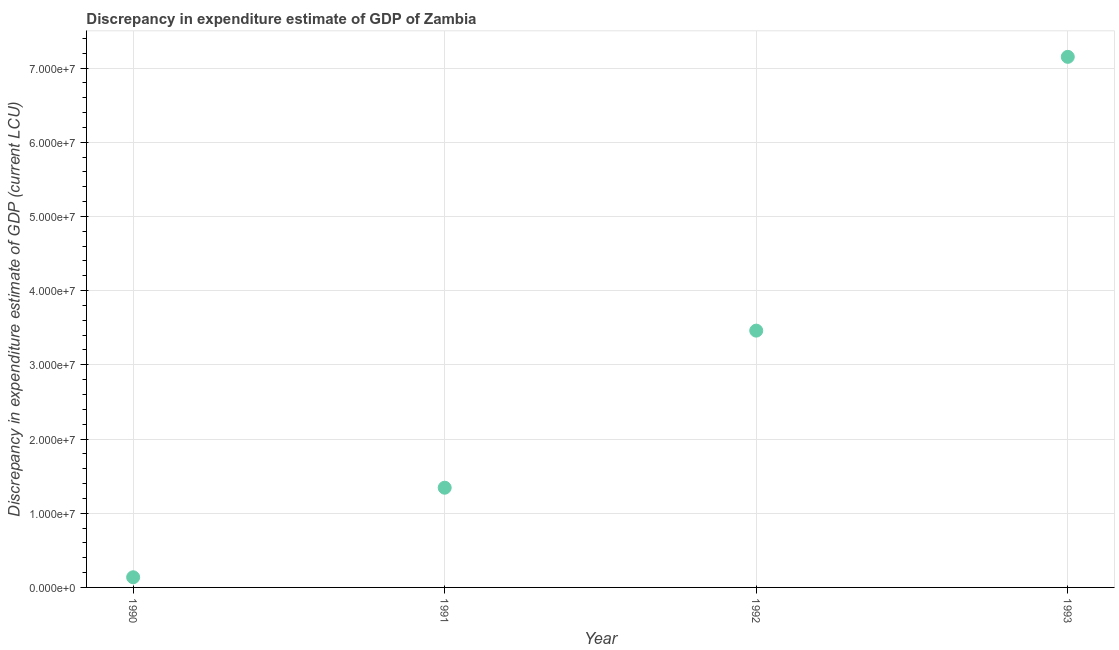What is the discrepancy in expenditure estimate of gdp in 1990?
Keep it short and to the point. 1.37e+06. Across all years, what is the maximum discrepancy in expenditure estimate of gdp?
Your response must be concise. 7.15e+07. Across all years, what is the minimum discrepancy in expenditure estimate of gdp?
Offer a terse response. 1.37e+06. In which year was the discrepancy in expenditure estimate of gdp maximum?
Your response must be concise. 1993. What is the sum of the discrepancy in expenditure estimate of gdp?
Offer a terse response. 1.21e+08. What is the difference between the discrepancy in expenditure estimate of gdp in 1990 and 1992?
Your answer should be compact. -3.32e+07. What is the average discrepancy in expenditure estimate of gdp per year?
Give a very brief answer. 3.02e+07. What is the median discrepancy in expenditure estimate of gdp?
Your answer should be compact. 2.40e+07. Do a majority of the years between 1991 and 1992 (inclusive) have discrepancy in expenditure estimate of gdp greater than 44000000 LCU?
Your response must be concise. No. What is the ratio of the discrepancy in expenditure estimate of gdp in 1992 to that in 1993?
Your answer should be compact. 0.48. What is the difference between the highest and the second highest discrepancy in expenditure estimate of gdp?
Keep it short and to the point. 3.69e+07. Is the sum of the discrepancy in expenditure estimate of gdp in 1990 and 1992 greater than the maximum discrepancy in expenditure estimate of gdp across all years?
Ensure brevity in your answer.  No. What is the difference between the highest and the lowest discrepancy in expenditure estimate of gdp?
Make the answer very short. 7.01e+07. In how many years, is the discrepancy in expenditure estimate of gdp greater than the average discrepancy in expenditure estimate of gdp taken over all years?
Provide a succinct answer. 2. How many dotlines are there?
Offer a terse response. 1. What is the difference between two consecutive major ticks on the Y-axis?
Offer a very short reply. 1.00e+07. Does the graph contain grids?
Give a very brief answer. Yes. What is the title of the graph?
Offer a very short reply. Discrepancy in expenditure estimate of GDP of Zambia. What is the label or title of the Y-axis?
Your answer should be compact. Discrepancy in expenditure estimate of GDP (current LCU). What is the Discrepancy in expenditure estimate of GDP (current LCU) in 1990?
Keep it short and to the point. 1.37e+06. What is the Discrepancy in expenditure estimate of GDP (current LCU) in 1991?
Offer a terse response. 1.34e+07. What is the Discrepancy in expenditure estimate of GDP (current LCU) in 1992?
Make the answer very short. 3.46e+07. What is the Discrepancy in expenditure estimate of GDP (current LCU) in 1993?
Offer a very short reply. 7.15e+07. What is the difference between the Discrepancy in expenditure estimate of GDP (current LCU) in 1990 and 1991?
Offer a very short reply. -1.21e+07. What is the difference between the Discrepancy in expenditure estimate of GDP (current LCU) in 1990 and 1992?
Provide a succinct answer. -3.32e+07. What is the difference between the Discrepancy in expenditure estimate of GDP (current LCU) in 1990 and 1993?
Provide a succinct answer. -7.01e+07. What is the difference between the Discrepancy in expenditure estimate of GDP (current LCU) in 1991 and 1992?
Your response must be concise. -2.12e+07. What is the difference between the Discrepancy in expenditure estimate of GDP (current LCU) in 1991 and 1993?
Offer a very short reply. -5.81e+07. What is the difference between the Discrepancy in expenditure estimate of GDP (current LCU) in 1992 and 1993?
Provide a short and direct response. -3.69e+07. What is the ratio of the Discrepancy in expenditure estimate of GDP (current LCU) in 1990 to that in 1991?
Give a very brief answer. 0.1. What is the ratio of the Discrepancy in expenditure estimate of GDP (current LCU) in 1990 to that in 1993?
Keep it short and to the point. 0.02. What is the ratio of the Discrepancy in expenditure estimate of GDP (current LCU) in 1991 to that in 1992?
Make the answer very short. 0.39. What is the ratio of the Discrepancy in expenditure estimate of GDP (current LCU) in 1991 to that in 1993?
Keep it short and to the point. 0.19. What is the ratio of the Discrepancy in expenditure estimate of GDP (current LCU) in 1992 to that in 1993?
Make the answer very short. 0.48. 